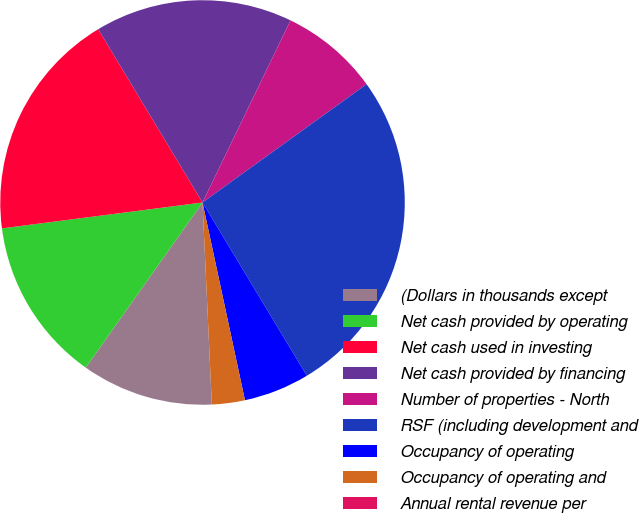Convert chart. <chart><loc_0><loc_0><loc_500><loc_500><pie_chart><fcel>(Dollars in thousands except<fcel>Net cash provided by operating<fcel>Net cash used in investing<fcel>Net cash provided by financing<fcel>Number of properties - North<fcel>RSF (including development and<fcel>Occupancy of operating<fcel>Occupancy of operating and<fcel>Annual rental revenue per<nl><fcel>10.53%<fcel>13.16%<fcel>18.42%<fcel>15.79%<fcel>7.89%<fcel>26.32%<fcel>5.26%<fcel>2.63%<fcel>0.0%<nl></chart> 